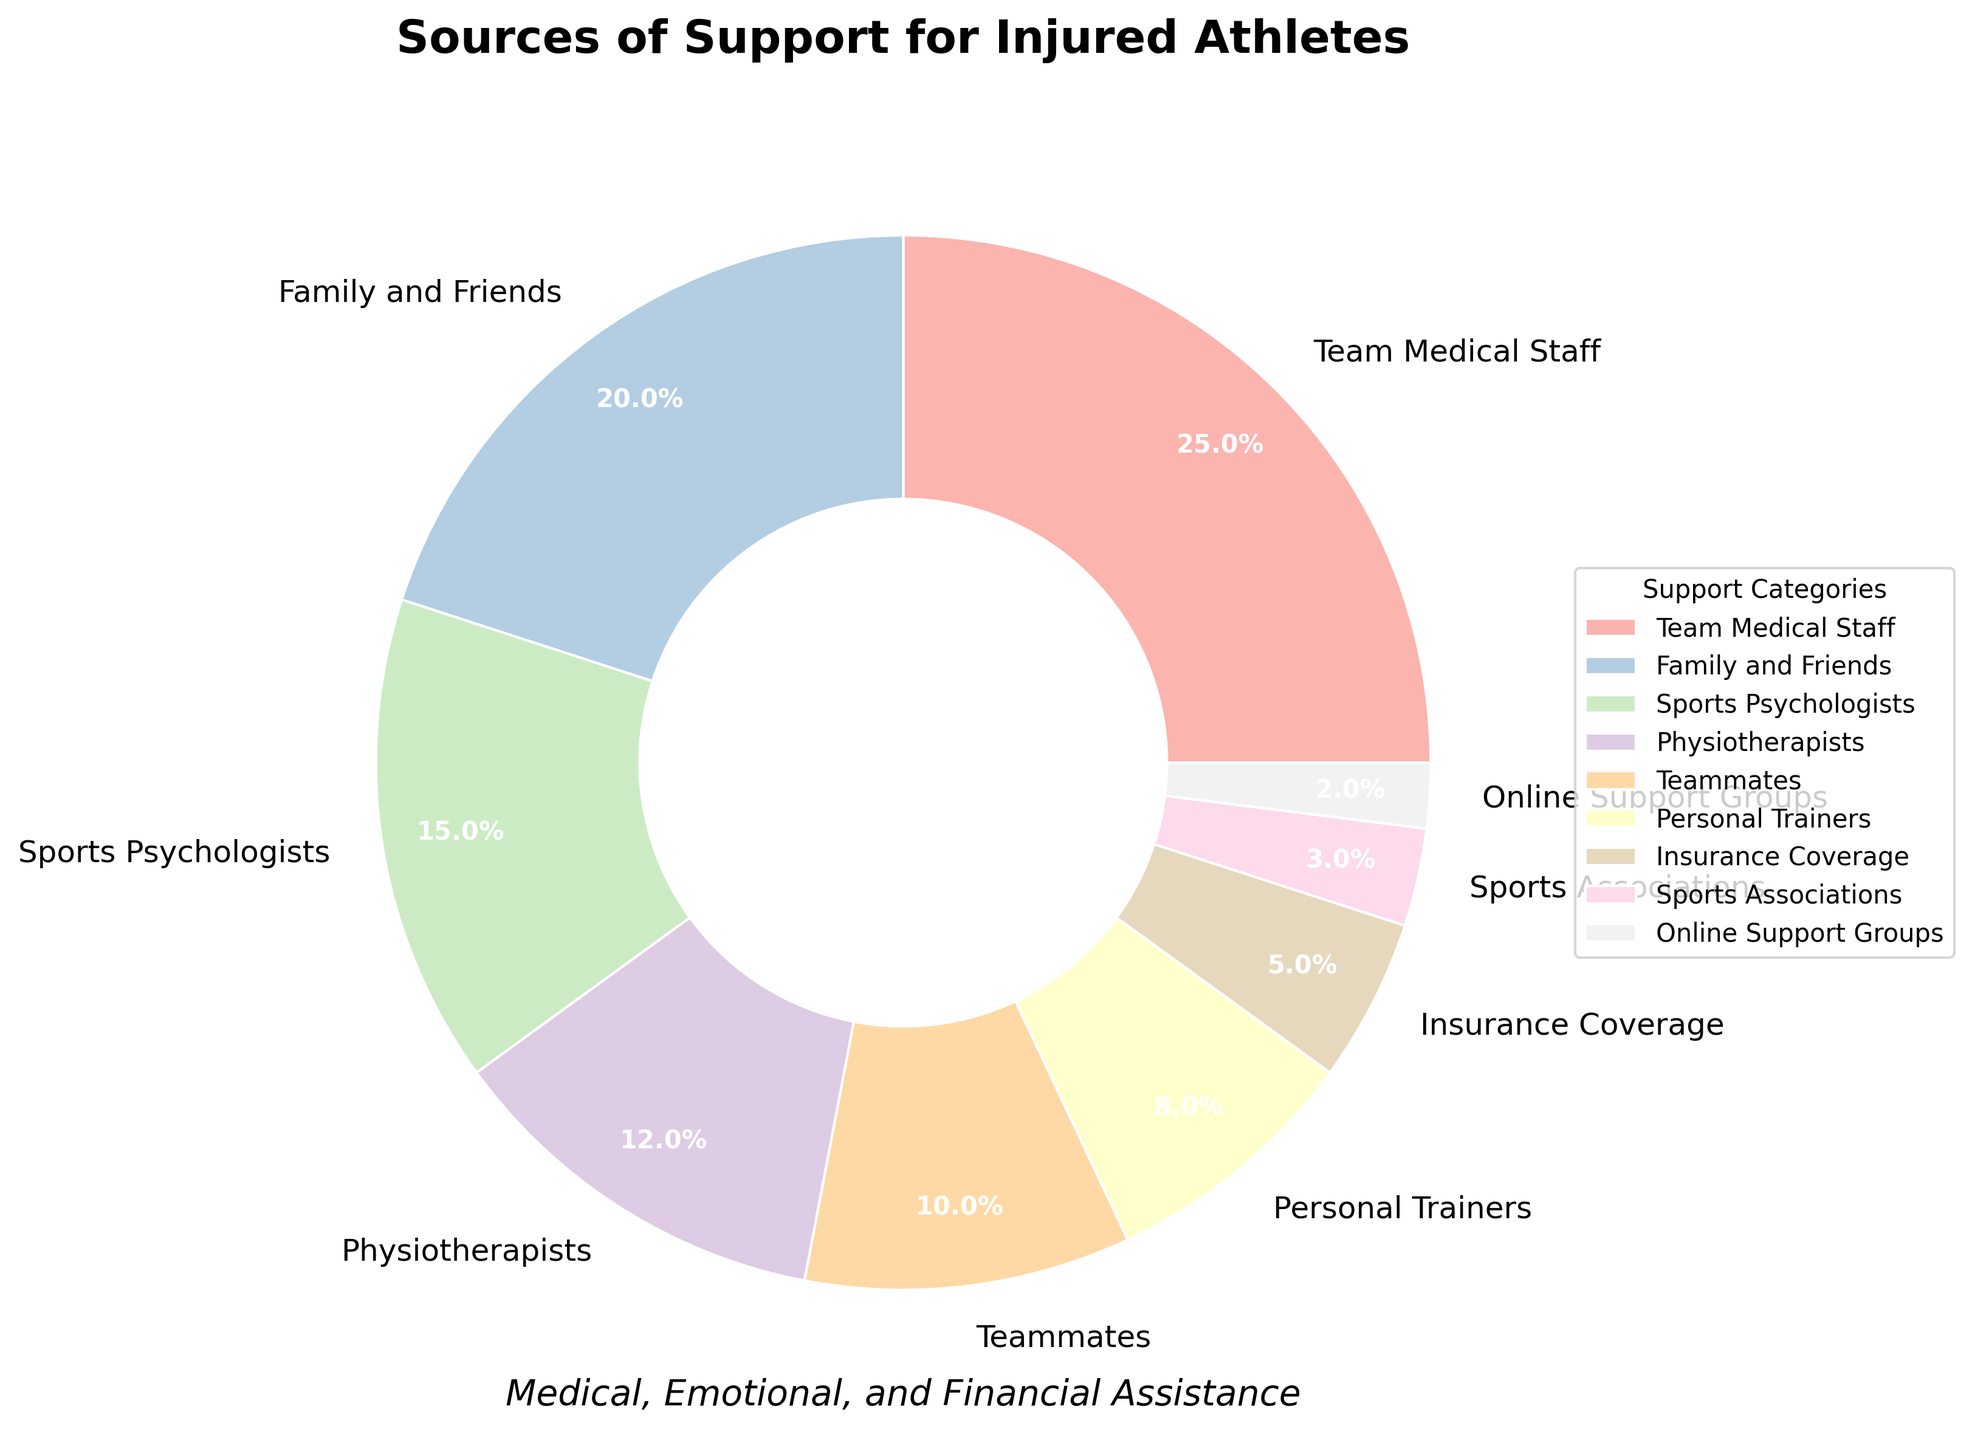What is the most common source of support for injured athletes? The largest segment of the pie chart represents the most common source of support. The figure shows that "Team Medical Staff" has the largest segment, making it the most common source.
Answer: Team Medical Staff How do the percentages of support from family and friends compare to support from teammates? The pie chart indicates the percentages for each category. Family and Friends have 20%, while Teammates have 10%. Comparing these values, Family and Friends provide double the percentage of support compared to Teammates.
Answer: Family and Friends is double that of Teammates What is the combined percentage of support provided by personal trainers and online support groups? Adding the percentages for Personal Trainers (8%) and Online Support Groups (2%) gives a combined total. Calculation: 8% + 2% = 10%.
Answer: 10% What is the difference in percentage points between support from sports psychologists and insurance coverage? The figure shows that Sports Psychologists provide 15% support, while Insurance Coverage provides 5%. The difference is calculated as 15% - 5% = 10%.
Answer: 10% Are physiotherapists or sports associations a more common source of support? The pie chart shows 12% for Physiotherapists and 3% for Sports Associations. Physiotherapists have a higher percentage and are therefore more common.
Answer: Physiotherapists Which category provides more support: Online Support Groups or Sports Associations? The pie chart shows the percentages for each category. Online Support Groups provide 2% support, while Sports Associations provide 3%. Therefore, Sports Associations provide more support.
Answer: Sports Associations What is the average percentage of support from family and friends, teammates, and personal trainers? To find this, add the percentages of Family and Friends (20%), Teammates (10%), and Personal Trainers (8%), then divide by the number of categories (3). Calculation: (20% + 10% + 8%) / 3 = 38% / 3 = 12.67%
Answer: 12.67% By how much does the support from the team medical staff exceed that from personal trainers? The pie chart shows 25% support from Team Medical Staff and 8% from Personal Trainers. The difference is 25% - 8% = 17%.
Answer: 17% Which two sources of support combined provide the largest percentage of support? Quickly glance through the pie chart, combine percentages, and verify. The highest individual percentages are Team Medical Staff (25%) and Family and Friends (20%), combining for 45%.
Answer: Team Medical Staff and Family and Friends How does the percentage of support from sports psychologists compare to the percentage from physiotherapists? The pie chart shows 15% support from Sports Psychologists and 12% from Physiotherapists. Sports Psychologists provide a higher percentage.
Answer: Sports Psychologists > Physiotherapists 